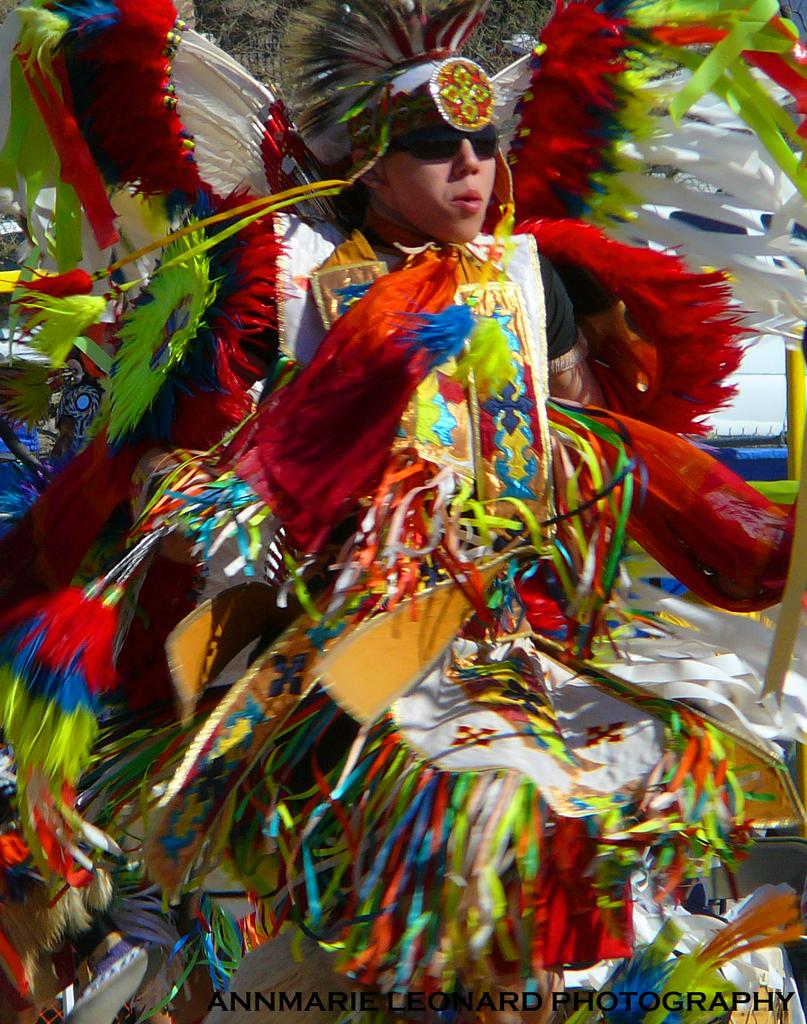What is present in the image? There is a person in the image. Can you describe the person's attire? The person is wearing colorful attire. Where is the person positioned in the image? The person is standing in the front. What accessory is the person wearing? The person is wearing glasses. Can you hear the person whistling in the image? There is no indication of sound or whistling in the image; it is a still image. Is the person in the image a girl? The provided facts do not specify the person's gender, so it cannot be determined from the image. 